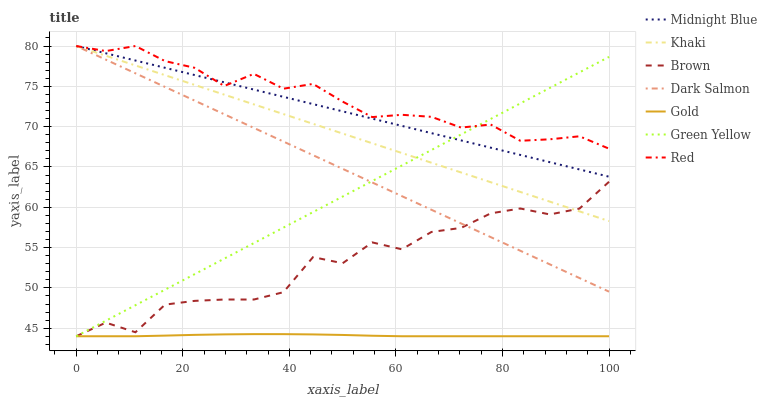Does Gold have the minimum area under the curve?
Answer yes or no. Yes. Does Red have the maximum area under the curve?
Answer yes or no. Yes. Does Khaki have the minimum area under the curve?
Answer yes or no. No. Does Khaki have the maximum area under the curve?
Answer yes or no. No. Is Dark Salmon the smoothest?
Answer yes or no. Yes. Is Brown the roughest?
Answer yes or no. Yes. Is Khaki the smoothest?
Answer yes or no. No. Is Khaki the roughest?
Answer yes or no. No. Does Khaki have the lowest value?
Answer yes or no. No. Does Red have the highest value?
Answer yes or no. Yes. Does Gold have the highest value?
Answer yes or no. No. Is Gold less than Red?
Answer yes or no. Yes. Is Midnight Blue greater than Brown?
Answer yes or no. Yes. Does Gold intersect Red?
Answer yes or no. No. 